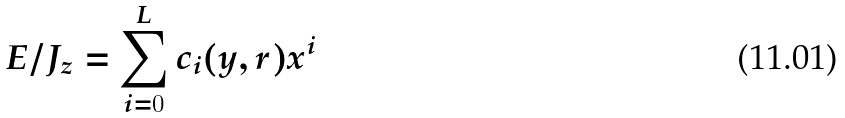Convert formula to latex. <formula><loc_0><loc_0><loc_500><loc_500>E / J _ { z } = \sum _ { i = 0 } ^ { L } c _ { i } ( y , r ) x ^ { i }</formula> 